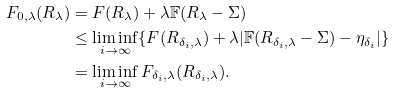Convert formula to latex. <formula><loc_0><loc_0><loc_500><loc_500>F _ { 0 , \lambda } ( R _ { \lambda } ) & = F ( R _ { \lambda } ) + \lambda \mathbb { F } ( R _ { \lambda } - \Sigma ) \\ & \leq \liminf _ { i \to \infty } \{ F ( R _ { \delta _ { i } , \lambda } ) + \lambda | \mathbb { F } ( R _ { \delta _ { i } , \lambda } - \Sigma ) - \eta _ { \delta _ { i } } | \} \\ & = \liminf _ { i \to \infty } F _ { \delta _ { i } , \lambda } ( R _ { \delta _ { i } , \lambda } ) .</formula> 